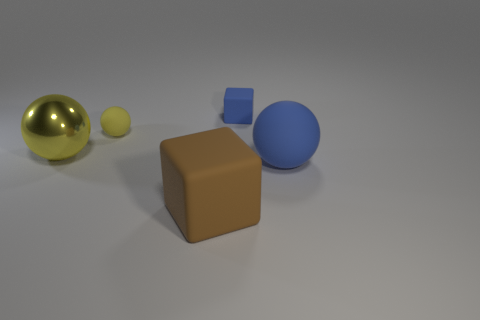Are there any other things that are made of the same material as the big yellow thing?
Keep it short and to the point. No. How many other objects are there of the same material as the tiny sphere?
Your answer should be very brief. 3. Is the size of the metal object the same as the thing right of the tiny rubber cube?
Keep it short and to the point. Yes. Is the number of tiny yellow things in front of the metal sphere less than the number of big shiny things that are in front of the tiny blue matte block?
Offer a very short reply. Yes. There is a block that is behind the large metal ball; what is its size?
Your response must be concise. Small. Do the yellow shiny ball and the brown matte thing have the same size?
Provide a succinct answer. Yes. How many objects are both on the right side of the tiny yellow rubber sphere and behind the big shiny object?
Ensure brevity in your answer.  1. What number of cyan objects are tiny matte blocks or tiny rubber things?
Offer a terse response. 0. How many matte objects are big green balls or large cubes?
Provide a short and direct response. 1. Are there any small red cubes?
Make the answer very short. No. 